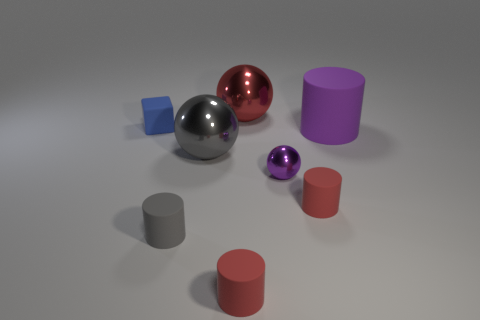Is the number of large gray balls greater than the number of large brown spheres?
Give a very brief answer. Yes. What number of red objects are the same size as the purple rubber object?
Offer a very short reply. 1. Are the small purple sphere and the red thing that is behind the gray shiny thing made of the same material?
Give a very brief answer. Yes. Is the number of blue rubber blocks less than the number of small things?
Offer a terse response. Yes. Is there anything else that is the same color as the small ball?
Give a very brief answer. Yes. The gray object that is the same material as the small purple ball is what shape?
Keep it short and to the point. Sphere. There is a small red cylinder that is on the right side of the large thing behind the big purple matte cylinder; what number of tiny red matte cylinders are behind it?
Ensure brevity in your answer.  0. The rubber object that is to the left of the large gray shiny sphere and in front of the purple ball has what shape?
Offer a very short reply. Cylinder. Is the number of things behind the small blue cube less than the number of small rubber things?
Provide a short and direct response. Yes. What number of tiny objects are purple matte things or gray spheres?
Make the answer very short. 0. 